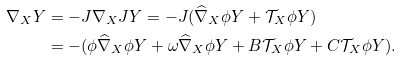Convert formula to latex. <formula><loc_0><loc_0><loc_500><loc_500>\nabla _ { X } Y & = - J \nabla _ { X } J Y = - J ( \widehat { \nabla } _ { X } \phi Y + \mathcal { T } _ { X } \phi Y ) \\ & = - ( \phi \widehat { \nabla } _ { X } \phi Y + \omega \widehat { \nabla } _ { X } \phi Y + B \mathcal { T } _ { X } \phi Y + C \mathcal { T } _ { X } \phi Y ) .</formula> 